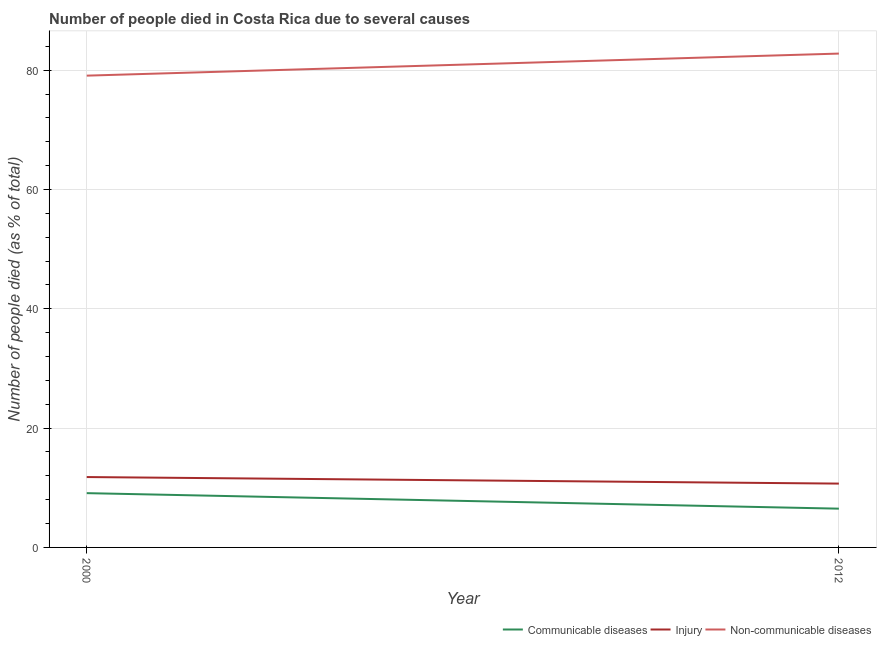How many different coloured lines are there?
Ensure brevity in your answer.  3. Is the number of lines equal to the number of legend labels?
Offer a very short reply. Yes. What is the number of people who dies of non-communicable diseases in 2012?
Give a very brief answer. 82.8. Across all years, what is the maximum number of people who died of injury?
Provide a short and direct response. 11.8. Across all years, what is the minimum number of people who dies of non-communicable diseases?
Offer a very short reply. 79.1. In which year was the number of people who dies of non-communicable diseases maximum?
Ensure brevity in your answer.  2012. In which year was the number of people who dies of non-communicable diseases minimum?
Give a very brief answer. 2000. What is the difference between the number of people who dies of non-communicable diseases in 2000 and that in 2012?
Provide a short and direct response. -3.7. What is the difference between the number of people who died of communicable diseases in 2012 and the number of people who died of injury in 2000?
Provide a succinct answer. -5.3. What is the average number of people who died of injury per year?
Make the answer very short. 11.25. In the year 2000, what is the difference between the number of people who died of injury and number of people who died of communicable diseases?
Offer a terse response. 2.7. In how many years, is the number of people who died of injury greater than 4 %?
Your answer should be very brief. 2. What is the ratio of the number of people who dies of non-communicable diseases in 2000 to that in 2012?
Your response must be concise. 0.96. Is the number of people who died of injury in 2000 less than that in 2012?
Your answer should be very brief. No. Is the number of people who died of communicable diseases strictly greater than the number of people who dies of non-communicable diseases over the years?
Your answer should be very brief. No. Is the number of people who dies of non-communicable diseases strictly less than the number of people who died of communicable diseases over the years?
Your response must be concise. No. How many lines are there?
Provide a succinct answer. 3. What is the difference between two consecutive major ticks on the Y-axis?
Provide a short and direct response. 20. Are the values on the major ticks of Y-axis written in scientific E-notation?
Provide a succinct answer. No. Does the graph contain grids?
Your answer should be very brief. Yes. How are the legend labels stacked?
Keep it short and to the point. Horizontal. What is the title of the graph?
Your answer should be compact. Number of people died in Costa Rica due to several causes. What is the label or title of the X-axis?
Make the answer very short. Year. What is the label or title of the Y-axis?
Your response must be concise. Number of people died (as % of total). What is the Number of people died (as % of total) of Injury in 2000?
Make the answer very short. 11.8. What is the Number of people died (as % of total) in Non-communicable diseases in 2000?
Your answer should be compact. 79.1. What is the Number of people died (as % of total) in Non-communicable diseases in 2012?
Your answer should be compact. 82.8. Across all years, what is the maximum Number of people died (as % of total) in Non-communicable diseases?
Your answer should be very brief. 82.8. Across all years, what is the minimum Number of people died (as % of total) of Communicable diseases?
Provide a succinct answer. 6.5. Across all years, what is the minimum Number of people died (as % of total) in Injury?
Ensure brevity in your answer.  10.7. Across all years, what is the minimum Number of people died (as % of total) in Non-communicable diseases?
Ensure brevity in your answer.  79.1. What is the total Number of people died (as % of total) of Communicable diseases in the graph?
Offer a very short reply. 15.6. What is the total Number of people died (as % of total) in Non-communicable diseases in the graph?
Provide a short and direct response. 161.9. What is the difference between the Number of people died (as % of total) in Injury in 2000 and that in 2012?
Your answer should be compact. 1.1. What is the difference between the Number of people died (as % of total) of Communicable diseases in 2000 and the Number of people died (as % of total) of Non-communicable diseases in 2012?
Your response must be concise. -73.7. What is the difference between the Number of people died (as % of total) in Injury in 2000 and the Number of people died (as % of total) in Non-communicable diseases in 2012?
Provide a succinct answer. -71. What is the average Number of people died (as % of total) in Communicable diseases per year?
Offer a very short reply. 7.8. What is the average Number of people died (as % of total) of Injury per year?
Offer a terse response. 11.25. What is the average Number of people died (as % of total) in Non-communicable diseases per year?
Your answer should be compact. 80.95. In the year 2000, what is the difference between the Number of people died (as % of total) in Communicable diseases and Number of people died (as % of total) in Non-communicable diseases?
Make the answer very short. -70. In the year 2000, what is the difference between the Number of people died (as % of total) in Injury and Number of people died (as % of total) in Non-communicable diseases?
Your answer should be compact. -67.3. In the year 2012, what is the difference between the Number of people died (as % of total) in Communicable diseases and Number of people died (as % of total) in Injury?
Your answer should be very brief. -4.2. In the year 2012, what is the difference between the Number of people died (as % of total) of Communicable diseases and Number of people died (as % of total) of Non-communicable diseases?
Your response must be concise. -76.3. In the year 2012, what is the difference between the Number of people died (as % of total) in Injury and Number of people died (as % of total) in Non-communicable diseases?
Your answer should be very brief. -72.1. What is the ratio of the Number of people died (as % of total) of Injury in 2000 to that in 2012?
Provide a succinct answer. 1.1. What is the ratio of the Number of people died (as % of total) in Non-communicable diseases in 2000 to that in 2012?
Make the answer very short. 0.96. What is the difference between the highest and the second highest Number of people died (as % of total) of Communicable diseases?
Make the answer very short. 2.6. What is the difference between the highest and the second highest Number of people died (as % of total) in Injury?
Make the answer very short. 1.1. What is the difference between the highest and the second highest Number of people died (as % of total) of Non-communicable diseases?
Offer a very short reply. 3.7. What is the difference between the highest and the lowest Number of people died (as % of total) in Injury?
Provide a succinct answer. 1.1. 